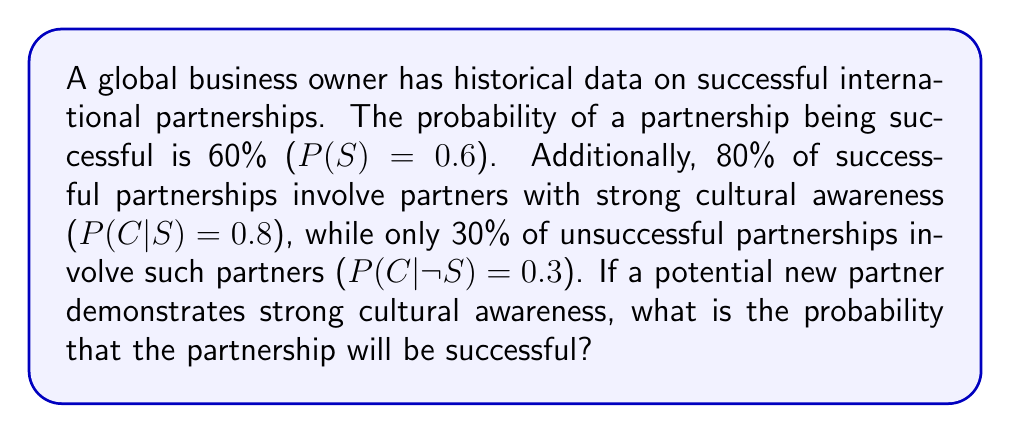Show me your answer to this math problem. To solve this problem, we'll use Bayes' theorem:

$$P(S|C) = \frac{P(C|S) \cdot P(S)}{P(C)}$$

We're given:
$P(S) = 0.6$ (prior probability of success)
$P(C|S) = 0.8$ (probability of cultural awareness given success)
$P(C|¬S) = 0.3$ (probability of cultural awareness given no success)

Step 1: Calculate $P(C)$ using the law of total probability:
$$P(C) = P(C|S) \cdot P(S) + P(C|¬S) \cdot P(¬S)$$
$$P(C) = 0.8 \cdot 0.6 + 0.3 \cdot (1 - 0.6)$$
$$P(C) = 0.48 + 0.12 = 0.6$$

Step 2: Apply Bayes' theorem:
$$P(S|C) = \frac{0.8 \cdot 0.6}{0.6}$$
$$P(S|C) = \frac{0.48}{0.6} = 0.8$$

Therefore, the probability of a successful partnership given that the partner demonstrates strong cultural awareness is 0.8 or 80%.
Answer: 0.8 